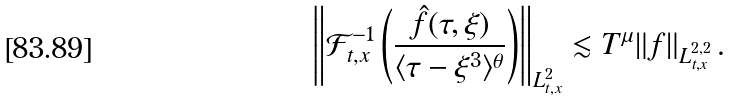<formula> <loc_0><loc_0><loc_500><loc_500>\left \| { \mathcal { F } } ^ { - 1 } _ { t , x } \left ( \frac { \hat { f } ( \tau , \xi ) } { \langle \tau - \xi ^ { 3 } \rangle ^ { \theta } } \right ) \right \| _ { L ^ { 2 } _ { t , x } } \lesssim T ^ { \mu } \| f \| _ { L ^ { 2 , 2 } _ { t , x } } \, .</formula> 